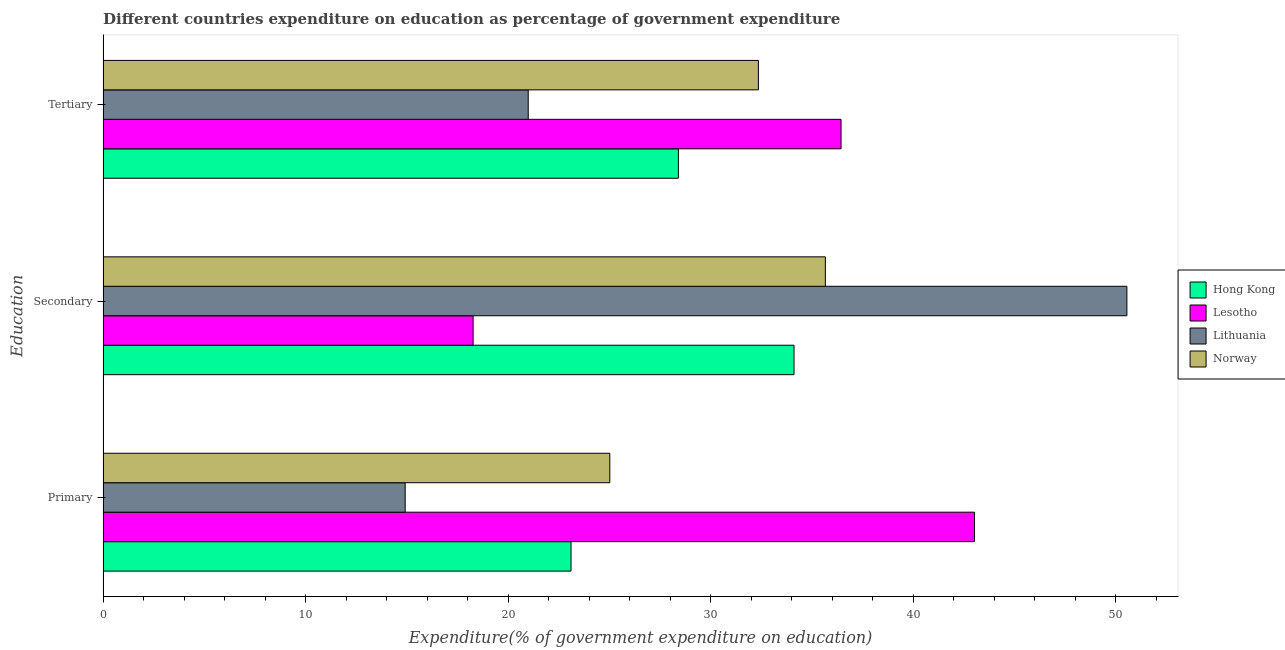Are the number of bars per tick equal to the number of legend labels?
Your answer should be compact. Yes. What is the label of the 2nd group of bars from the top?
Offer a very short reply. Secondary. What is the expenditure on tertiary education in Norway?
Your response must be concise. 32.36. Across all countries, what is the maximum expenditure on primary education?
Provide a short and direct response. 43.04. Across all countries, what is the minimum expenditure on secondary education?
Your answer should be very brief. 18.27. In which country was the expenditure on primary education maximum?
Make the answer very short. Lesotho. In which country was the expenditure on secondary education minimum?
Make the answer very short. Lesotho. What is the total expenditure on tertiary education in the graph?
Offer a terse response. 118.21. What is the difference between the expenditure on primary education in Lithuania and that in Norway?
Provide a succinct answer. -10.11. What is the difference between the expenditure on tertiary education in Lithuania and the expenditure on primary education in Norway?
Give a very brief answer. -4.03. What is the average expenditure on tertiary education per country?
Provide a succinct answer. 29.55. What is the difference between the expenditure on primary education and expenditure on tertiary education in Lithuania?
Provide a short and direct response. -6.08. What is the ratio of the expenditure on tertiary education in Lithuania to that in Norway?
Provide a succinct answer. 0.65. Is the expenditure on primary education in Lithuania less than that in Lesotho?
Offer a terse response. Yes. Is the difference between the expenditure on tertiary education in Hong Kong and Norway greater than the difference between the expenditure on secondary education in Hong Kong and Norway?
Provide a succinct answer. No. What is the difference between the highest and the second highest expenditure on primary education?
Your response must be concise. 18.01. What is the difference between the highest and the lowest expenditure on primary education?
Offer a very short reply. 28.12. Is the sum of the expenditure on primary education in Lesotho and Hong Kong greater than the maximum expenditure on tertiary education across all countries?
Your answer should be very brief. Yes. What does the 2nd bar from the top in Secondary represents?
Offer a terse response. Lithuania. What does the 3rd bar from the bottom in Secondary represents?
Make the answer very short. Lithuania. Is it the case that in every country, the sum of the expenditure on primary education and expenditure on secondary education is greater than the expenditure on tertiary education?
Make the answer very short. Yes. How many bars are there?
Your answer should be very brief. 12. Are all the bars in the graph horizontal?
Provide a succinct answer. Yes. Are the values on the major ticks of X-axis written in scientific E-notation?
Give a very brief answer. No. How many legend labels are there?
Provide a short and direct response. 4. What is the title of the graph?
Keep it short and to the point. Different countries expenditure on education as percentage of government expenditure. What is the label or title of the X-axis?
Provide a short and direct response. Expenditure(% of government expenditure on education). What is the label or title of the Y-axis?
Your response must be concise. Education. What is the Expenditure(% of government expenditure on education) in Hong Kong in Primary?
Provide a short and direct response. 23.11. What is the Expenditure(% of government expenditure on education) of Lesotho in Primary?
Make the answer very short. 43.04. What is the Expenditure(% of government expenditure on education) in Lithuania in Primary?
Your answer should be compact. 14.92. What is the Expenditure(% of government expenditure on education) in Norway in Primary?
Keep it short and to the point. 25.02. What is the Expenditure(% of government expenditure on education) of Hong Kong in Secondary?
Give a very brief answer. 34.12. What is the Expenditure(% of government expenditure on education) in Lesotho in Secondary?
Ensure brevity in your answer.  18.27. What is the Expenditure(% of government expenditure on education) in Lithuania in Secondary?
Ensure brevity in your answer.  50.56. What is the Expenditure(% of government expenditure on education) of Norway in Secondary?
Provide a short and direct response. 35.67. What is the Expenditure(% of government expenditure on education) in Hong Kong in Tertiary?
Offer a terse response. 28.41. What is the Expenditure(% of government expenditure on education) of Lesotho in Tertiary?
Ensure brevity in your answer.  36.44. What is the Expenditure(% of government expenditure on education) of Lithuania in Tertiary?
Offer a very short reply. 20.99. What is the Expenditure(% of government expenditure on education) in Norway in Tertiary?
Give a very brief answer. 32.36. Across all Education, what is the maximum Expenditure(% of government expenditure on education) in Hong Kong?
Offer a terse response. 34.12. Across all Education, what is the maximum Expenditure(% of government expenditure on education) in Lesotho?
Your answer should be compact. 43.04. Across all Education, what is the maximum Expenditure(% of government expenditure on education) in Lithuania?
Ensure brevity in your answer.  50.56. Across all Education, what is the maximum Expenditure(% of government expenditure on education) of Norway?
Provide a succinct answer. 35.67. Across all Education, what is the minimum Expenditure(% of government expenditure on education) of Hong Kong?
Give a very brief answer. 23.11. Across all Education, what is the minimum Expenditure(% of government expenditure on education) of Lesotho?
Provide a succinct answer. 18.27. Across all Education, what is the minimum Expenditure(% of government expenditure on education) of Lithuania?
Give a very brief answer. 14.92. Across all Education, what is the minimum Expenditure(% of government expenditure on education) of Norway?
Offer a very short reply. 25.02. What is the total Expenditure(% of government expenditure on education) of Hong Kong in the graph?
Your answer should be very brief. 85.64. What is the total Expenditure(% of government expenditure on education) of Lesotho in the graph?
Offer a very short reply. 97.75. What is the total Expenditure(% of government expenditure on education) of Lithuania in the graph?
Ensure brevity in your answer.  86.47. What is the total Expenditure(% of government expenditure on education) in Norway in the graph?
Your answer should be very brief. 93.06. What is the difference between the Expenditure(% of government expenditure on education) of Hong Kong in Primary and that in Secondary?
Offer a very short reply. -11.01. What is the difference between the Expenditure(% of government expenditure on education) in Lesotho in Primary and that in Secondary?
Keep it short and to the point. 24.76. What is the difference between the Expenditure(% of government expenditure on education) in Lithuania in Primary and that in Secondary?
Ensure brevity in your answer.  -35.64. What is the difference between the Expenditure(% of government expenditure on education) of Norway in Primary and that in Secondary?
Provide a short and direct response. -10.64. What is the difference between the Expenditure(% of government expenditure on education) in Hong Kong in Primary and that in Tertiary?
Give a very brief answer. -5.3. What is the difference between the Expenditure(% of government expenditure on education) in Lesotho in Primary and that in Tertiary?
Keep it short and to the point. 6.59. What is the difference between the Expenditure(% of government expenditure on education) of Lithuania in Primary and that in Tertiary?
Give a very brief answer. -6.08. What is the difference between the Expenditure(% of government expenditure on education) in Norway in Primary and that in Tertiary?
Your answer should be compact. -7.34. What is the difference between the Expenditure(% of government expenditure on education) in Hong Kong in Secondary and that in Tertiary?
Offer a very short reply. 5.71. What is the difference between the Expenditure(% of government expenditure on education) of Lesotho in Secondary and that in Tertiary?
Offer a very short reply. -18.17. What is the difference between the Expenditure(% of government expenditure on education) of Lithuania in Secondary and that in Tertiary?
Your response must be concise. 29.57. What is the difference between the Expenditure(% of government expenditure on education) in Norway in Secondary and that in Tertiary?
Ensure brevity in your answer.  3.31. What is the difference between the Expenditure(% of government expenditure on education) in Hong Kong in Primary and the Expenditure(% of government expenditure on education) in Lesotho in Secondary?
Provide a succinct answer. 4.84. What is the difference between the Expenditure(% of government expenditure on education) of Hong Kong in Primary and the Expenditure(% of government expenditure on education) of Lithuania in Secondary?
Make the answer very short. -27.45. What is the difference between the Expenditure(% of government expenditure on education) of Hong Kong in Primary and the Expenditure(% of government expenditure on education) of Norway in Secondary?
Keep it short and to the point. -12.56. What is the difference between the Expenditure(% of government expenditure on education) of Lesotho in Primary and the Expenditure(% of government expenditure on education) of Lithuania in Secondary?
Provide a short and direct response. -7.52. What is the difference between the Expenditure(% of government expenditure on education) of Lesotho in Primary and the Expenditure(% of government expenditure on education) of Norway in Secondary?
Offer a terse response. 7.37. What is the difference between the Expenditure(% of government expenditure on education) in Lithuania in Primary and the Expenditure(% of government expenditure on education) in Norway in Secondary?
Your answer should be very brief. -20.75. What is the difference between the Expenditure(% of government expenditure on education) of Hong Kong in Primary and the Expenditure(% of government expenditure on education) of Lesotho in Tertiary?
Your answer should be compact. -13.34. What is the difference between the Expenditure(% of government expenditure on education) in Hong Kong in Primary and the Expenditure(% of government expenditure on education) in Lithuania in Tertiary?
Your answer should be compact. 2.11. What is the difference between the Expenditure(% of government expenditure on education) in Hong Kong in Primary and the Expenditure(% of government expenditure on education) in Norway in Tertiary?
Your answer should be very brief. -9.26. What is the difference between the Expenditure(% of government expenditure on education) of Lesotho in Primary and the Expenditure(% of government expenditure on education) of Lithuania in Tertiary?
Your answer should be compact. 22.04. What is the difference between the Expenditure(% of government expenditure on education) in Lesotho in Primary and the Expenditure(% of government expenditure on education) in Norway in Tertiary?
Your answer should be very brief. 10.67. What is the difference between the Expenditure(% of government expenditure on education) in Lithuania in Primary and the Expenditure(% of government expenditure on education) in Norway in Tertiary?
Make the answer very short. -17.45. What is the difference between the Expenditure(% of government expenditure on education) of Hong Kong in Secondary and the Expenditure(% of government expenditure on education) of Lesotho in Tertiary?
Keep it short and to the point. -2.32. What is the difference between the Expenditure(% of government expenditure on education) in Hong Kong in Secondary and the Expenditure(% of government expenditure on education) in Lithuania in Tertiary?
Provide a succinct answer. 13.13. What is the difference between the Expenditure(% of government expenditure on education) of Hong Kong in Secondary and the Expenditure(% of government expenditure on education) of Norway in Tertiary?
Your answer should be very brief. 1.76. What is the difference between the Expenditure(% of government expenditure on education) of Lesotho in Secondary and the Expenditure(% of government expenditure on education) of Lithuania in Tertiary?
Your answer should be very brief. -2.72. What is the difference between the Expenditure(% of government expenditure on education) of Lesotho in Secondary and the Expenditure(% of government expenditure on education) of Norway in Tertiary?
Offer a terse response. -14.09. What is the difference between the Expenditure(% of government expenditure on education) of Lithuania in Secondary and the Expenditure(% of government expenditure on education) of Norway in Tertiary?
Offer a terse response. 18.2. What is the average Expenditure(% of government expenditure on education) of Hong Kong per Education?
Provide a succinct answer. 28.55. What is the average Expenditure(% of government expenditure on education) in Lesotho per Education?
Keep it short and to the point. 32.58. What is the average Expenditure(% of government expenditure on education) of Lithuania per Education?
Keep it short and to the point. 28.82. What is the average Expenditure(% of government expenditure on education) in Norway per Education?
Give a very brief answer. 31.02. What is the difference between the Expenditure(% of government expenditure on education) of Hong Kong and Expenditure(% of government expenditure on education) of Lesotho in Primary?
Make the answer very short. -19.93. What is the difference between the Expenditure(% of government expenditure on education) in Hong Kong and Expenditure(% of government expenditure on education) in Lithuania in Primary?
Your response must be concise. 8.19. What is the difference between the Expenditure(% of government expenditure on education) in Hong Kong and Expenditure(% of government expenditure on education) in Norway in Primary?
Your answer should be compact. -1.92. What is the difference between the Expenditure(% of government expenditure on education) of Lesotho and Expenditure(% of government expenditure on education) of Lithuania in Primary?
Provide a succinct answer. 28.12. What is the difference between the Expenditure(% of government expenditure on education) in Lesotho and Expenditure(% of government expenditure on education) in Norway in Primary?
Your answer should be compact. 18.01. What is the difference between the Expenditure(% of government expenditure on education) in Lithuania and Expenditure(% of government expenditure on education) in Norway in Primary?
Offer a terse response. -10.11. What is the difference between the Expenditure(% of government expenditure on education) of Hong Kong and Expenditure(% of government expenditure on education) of Lesotho in Secondary?
Keep it short and to the point. 15.85. What is the difference between the Expenditure(% of government expenditure on education) of Hong Kong and Expenditure(% of government expenditure on education) of Lithuania in Secondary?
Offer a terse response. -16.44. What is the difference between the Expenditure(% of government expenditure on education) of Hong Kong and Expenditure(% of government expenditure on education) of Norway in Secondary?
Your answer should be compact. -1.55. What is the difference between the Expenditure(% of government expenditure on education) in Lesotho and Expenditure(% of government expenditure on education) in Lithuania in Secondary?
Offer a very short reply. -32.29. What is the difference between the Expenditure(% of government expenditure on education) of Lesotho and Expenditure(% of government expenditure on education) of Norway in Secondary?
Your answer should be very brief. -17.4. What is the difference between the Expenditure(% of government expenditure on education) in Lithuania and Expenditure(% of government expenditure on education) in Norway in Secondary?
Provide a short and direct response. 14.89. What is the difference between the Expenditure(% of government expenditure on education) in Hong Kong and Expenditure(% of government expenditure on education) in Lesotho in Tertiary?
Make the answer very short. -8.03. What is the difference between the Expenditure(% of government expenditure on education) in Hong Kong and Expenditure(% of government expenditure on education) in Lithuania in Tertiary?
Your answer should be very brief. 7.42. What is the difference between the Expenditure(% of government expenditure on education) in Hong Kong and Expenditure(% of government expenditure on education) in Norway in Tertiary?
Give a very brief answer. -3.95. What is the difference between the Expenditure(% of government expenditure on education) in Lesotho and Expenditure(% of government expenditure on education) in Lithuania in Tertiary?
Provide a short and direct response. 15.45. What is the difference between the Expenditure(% of government expenditure on education) of Lesotho and Expenditure(% of government expenditure on education) of Norway in Tertiary?
Your answer should be very brief. 4.08. What is the difference between the Expenditure(% of government expenditure on education) of Lithuania and Expenditure(% of government expenditure on education) of Norway in Tertiary?
Your answer should be very brief. -11.37. What is the ratio of the Expenditure(% of government expenditure on education) of Hong Kong in Primary to that in Secondary?
Keep it short and to the point. 0.68. What is the ratio of the Expenditure(% of government expenditure on education) of Lesotho in Primary to that in Secondary?
Give a very brief answer. 2.36. What is the ratio of the Expenditure(% of government expenditure on education) of Lithuania in Primary to that in Secondary?
Your answer should be compact. 0.29. What is the ratio of the Expenditure(% of government expenditure on education) of Norway in Primary to that in Secondary?
Provide a short and direct response. 0.7. What is the ratio of the Expenditure(% of government expenditure on education) of Hong Kong in Primary to that in Tertiary?
Provide a succinct answer. 0.81. What is the ratio of the Expenditure(% of government expenditure on education) in Lesotho in Primary to that in Tertiary?
Offer a terse response. 1.18. What is the ratio of the Expenditure(% of government expenditure on education) in Lithuania in Primary to that in Tertiary?
Offer a terse response. 0.71. What is the ratio of the Expenditure(% of government expenditure on education) of Norway in Primary to that in Tertiary?
Ensure brevity in your answer.  0.77. What is the ratio of the Expenditure(% of government expenditure on education) of Hong Kong in Secondary to that in Tertiary?
Provide a short and direct response. 1.2. What is the ratio of the Expenditure(% of government expenditure on education) of Lesotho in Secondary to that in Tertiary?
Give a very brief answer. 0.5. What is the ratio of the Expenditure(% of government expenditure on education) of Lithuania in Secondary to that in Tertiary?
Offer a terse response. 2.41. What is the ratio of the Expenditure(% of government expenditure on education) in Norway in Secondary to that in Tertiary?
Your answer should be compact. 1.1. What is the difference between the highest and the second highest Expenditure(% of government expenditure on education) in Hong Kong?
Provide a succinct answer. 5.71. What is the difference between the highest and the second highest Expenditure(% of government expenditure on education) of Lesotho?
Provide a short and direct response. 6.59. What is the difference between the highest and the second highest Expenditure(% of government expenditure on education) in Lithuania?
Ensure brevity in your answer.  29.57. What is the difference between the highest and the second highest Expenditure(% of government expenditure on education) of Norway?
Offer a terse response. 3.31. What is the difference between the highest and the lowest Expenditure(% of government expenditure on education) in Hong Kong?
Make the answer very short. 11.01. What is the difference between the highest and the lowest Expenditure(% of government expenditure on education) in Lesotho?
Your answer should be compact. 24.76. What is the difference between the highest and the lowest Expenditure(% of government expenditure on education) in Lithuania?
Your response must be concise. 35.64. What is the difference between the highest and the lowest Expenditure(% of government expenditure on education) in Norway?
Your response must be concise. 10.64. 